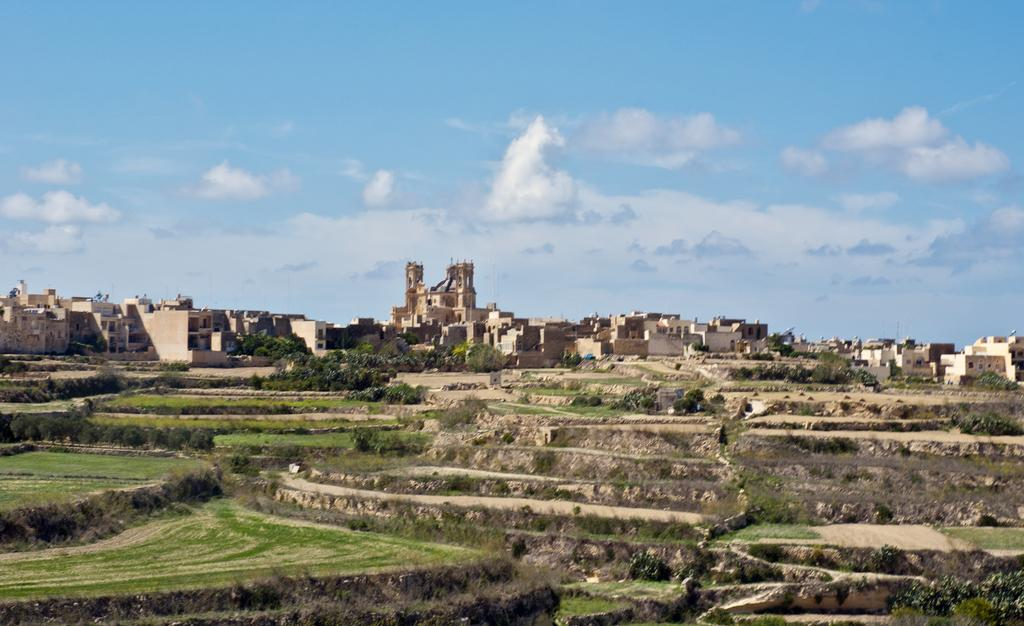What type of vegetation is present in the image? There is grass, plants, and trees in the image. What type of structures can be seen in the image? There are buildings in the image. What is visible in the background of the image? The sky is visible in the background of the image. What type of seed is being sold at the market in the image? There is no market or seed present in the image. Who is telling the joke in the image? There is no joke or person telling a joke in the image. 